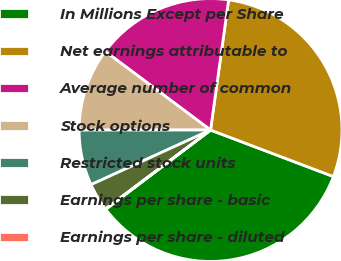Convert chart to OTSL. <chart><loc_0><loc_0><loc_500><loc_500><pie_chart><fcel>In Millions Except per Share<fcel>Net earnings attributable to<fcel>Average number of common<fcel>Stock options<fcel>Restricted stock units<fcel>Earnings per share - basic<fcel>Earnings per share - diluted<nl><fcel>33.93%<fcel>28.57%<fcel>16.99%<fcel>10.21%<fcel>6.82%<fcel>3.43%<fcel>0.05%<nl></chart> 